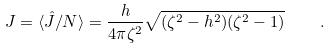Convert formula to latex. <formula><loc_0><loc_0><loc_500><loc_500>J = \langle \hat { J } / N \rangle = \frac { h } { 4 \pi \zeta ^ { 2 } } \sqrt { ( \zeta ^ { 2 } - h ^ { 2 } ) ( \zeta ^ { 2 } - 1 ) } \quad .</formula> 